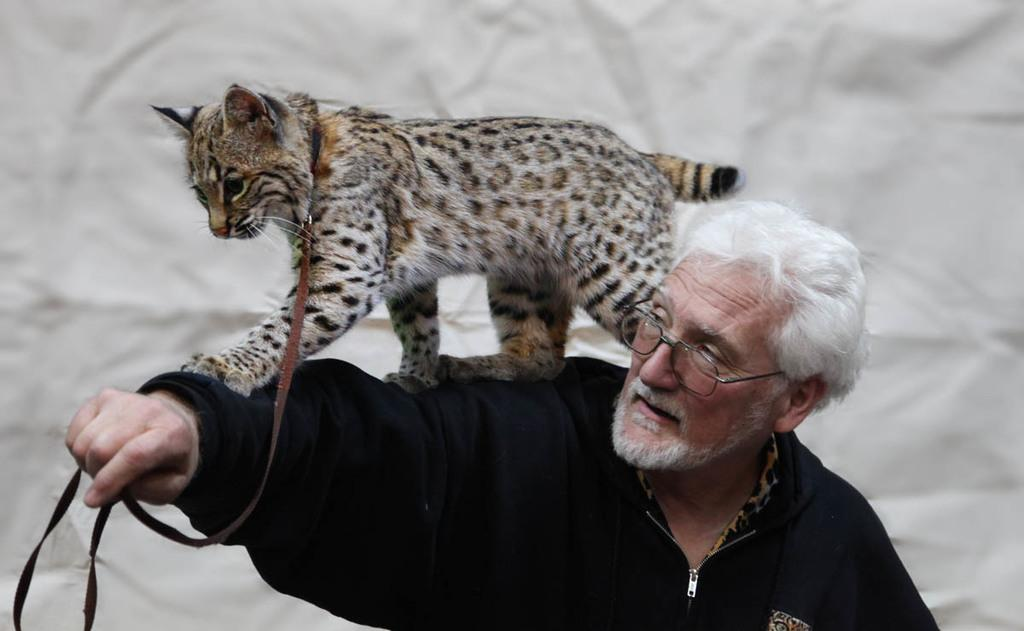Who or what is the main subject in the image? There is a person in the image. What other living creature is present in the image? There is a cat in the image. How is the cat dressed or accessorized? The cat is wearing a belt. What is the cat's position in relation to the person? The cat is on the person. What can be seen in the background of the image? There is a wall in the background of the image. What type of comparison can be made between the person and the cat in the image? There is no comparison being made between the person and the cat in the image; they are simply present together. 